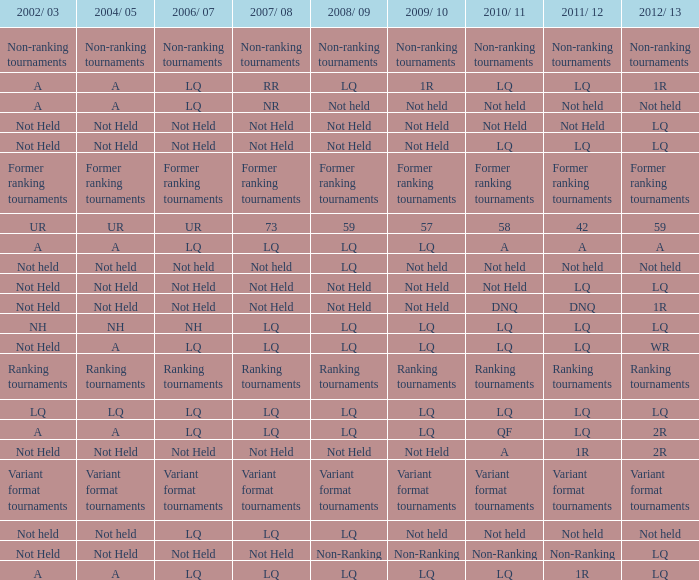Name the 2011/12 with 2008/09 of not held with 2010/11 of not held LQ, Not Held, Not held. 